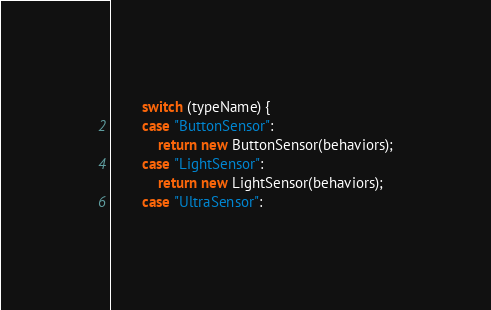Convert code to text. <code><loc_0><loc_0><loc_500><loc_500><_Java_>		switch (typeName) {
		case "ButtonSensor":
			return new ButtonSensor(behaviors);
		case "LightSensor":
			return new LightSensor(behaviors);
		case "UltraSensor":</code> 